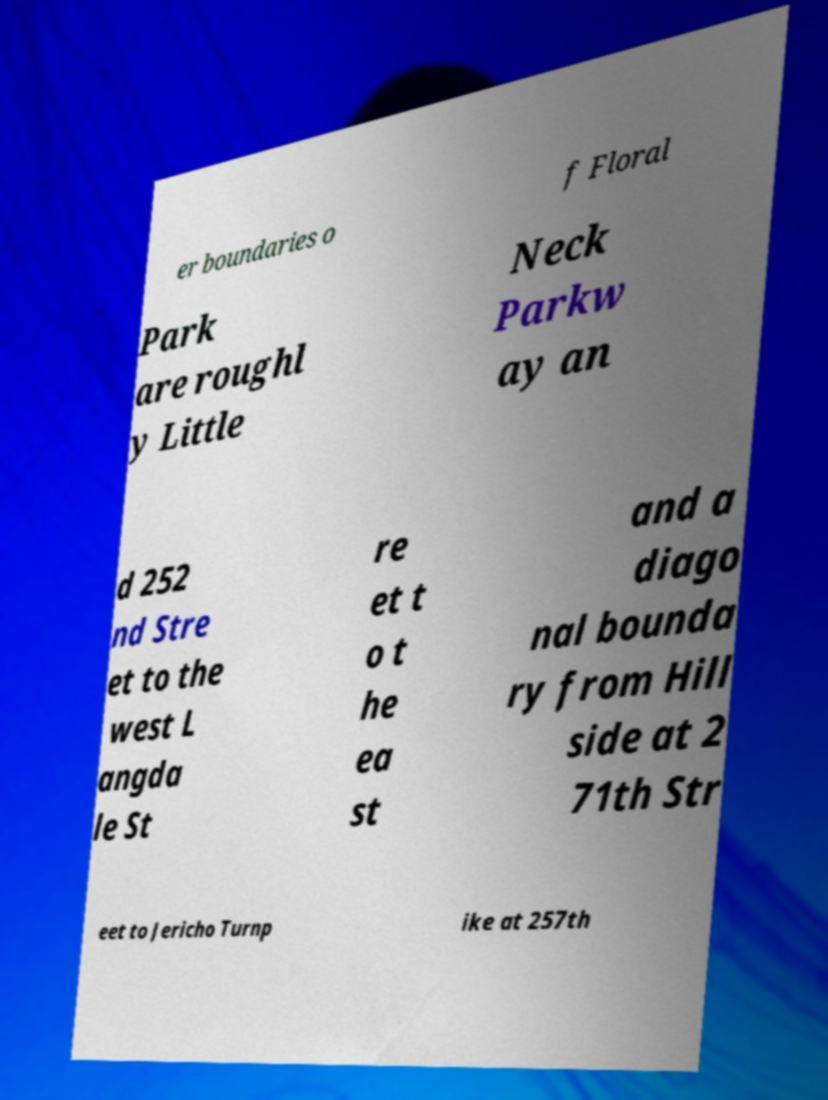Could you assist in decoding the text presented in this image and type it out clearly? er boundaries o f Floral Park are roughl y Little Neck Parkw ay an d 252 nd Stre et to the west L angda le St re et t o t he ea st and a diago nal bounda ry from Hill side at 2 71th Str eet to Jericho Turnp ike at 257th 